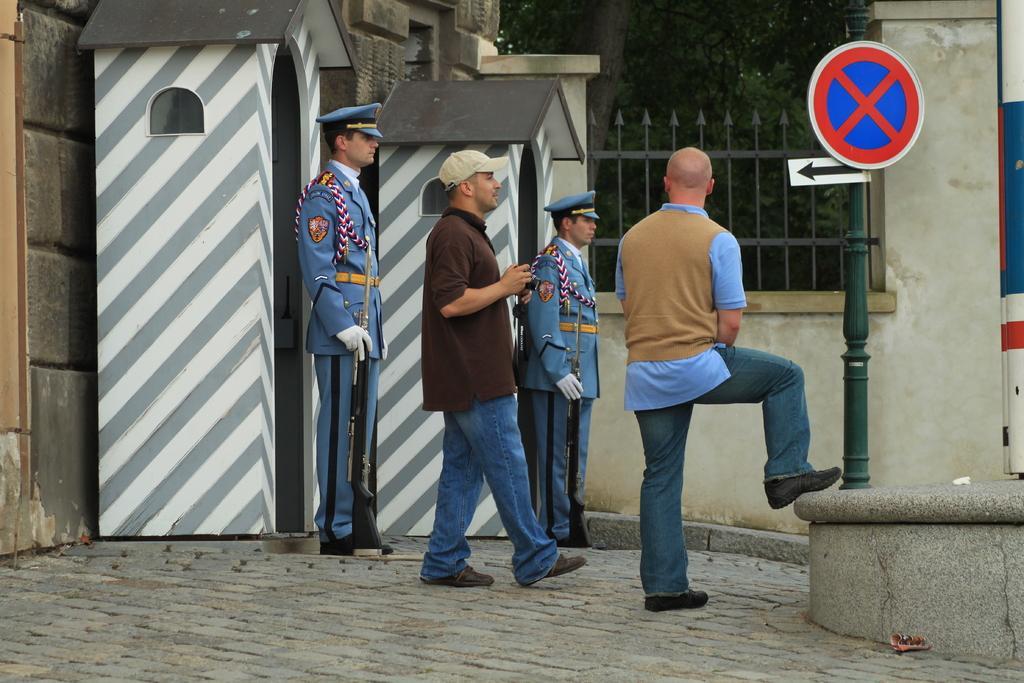Could you give a brief overview of what you see in this image? In the foreground of this image, there are four men standing on the ground and we can also see sign board, railing, two cardboard huts, wall, and tree in this image. 